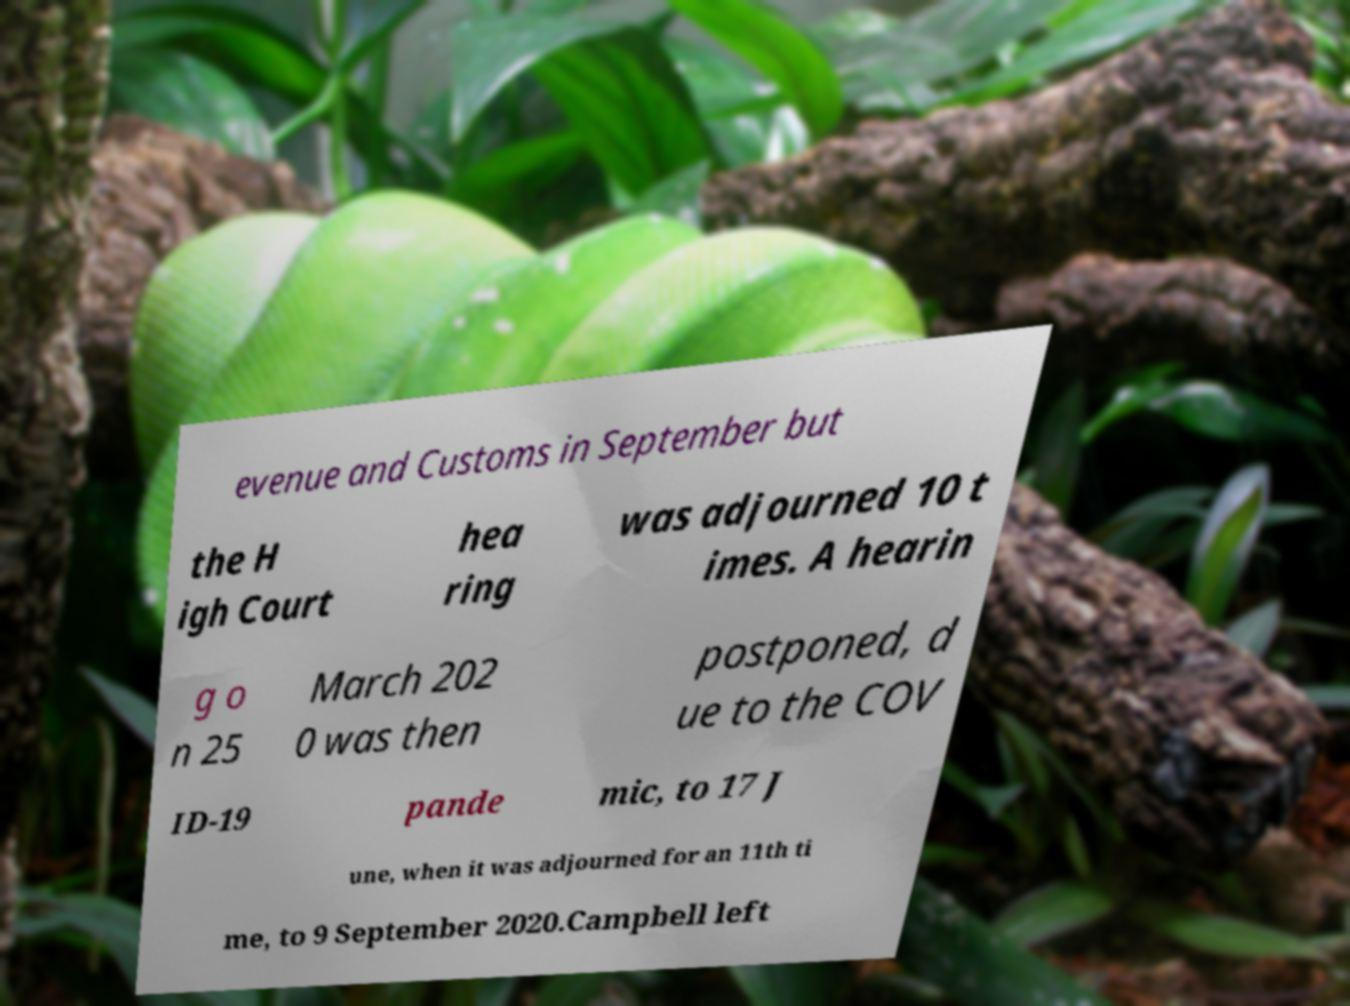Can you accurately transcribe the text from the provided image for me? evenue and Customs in September but the H igh Court hea ring was adjourned 10 t imes. A hearin g o n 25 March 202 0 was then postponed, d ue to the COV ID-19 pande mic, to 17 J une, when it was adjourned for an 11th ti me, to 9 September 2020.Campbell left 